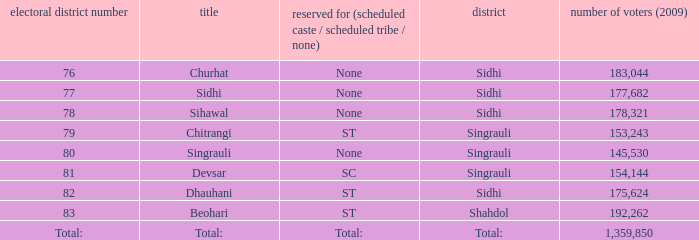What is Beohari's highest number of electorates? 192262.0. 